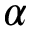Convert formula to latex. <formula><loc_0><loc_0><loc_500><loc_500>\alpha</formula> 